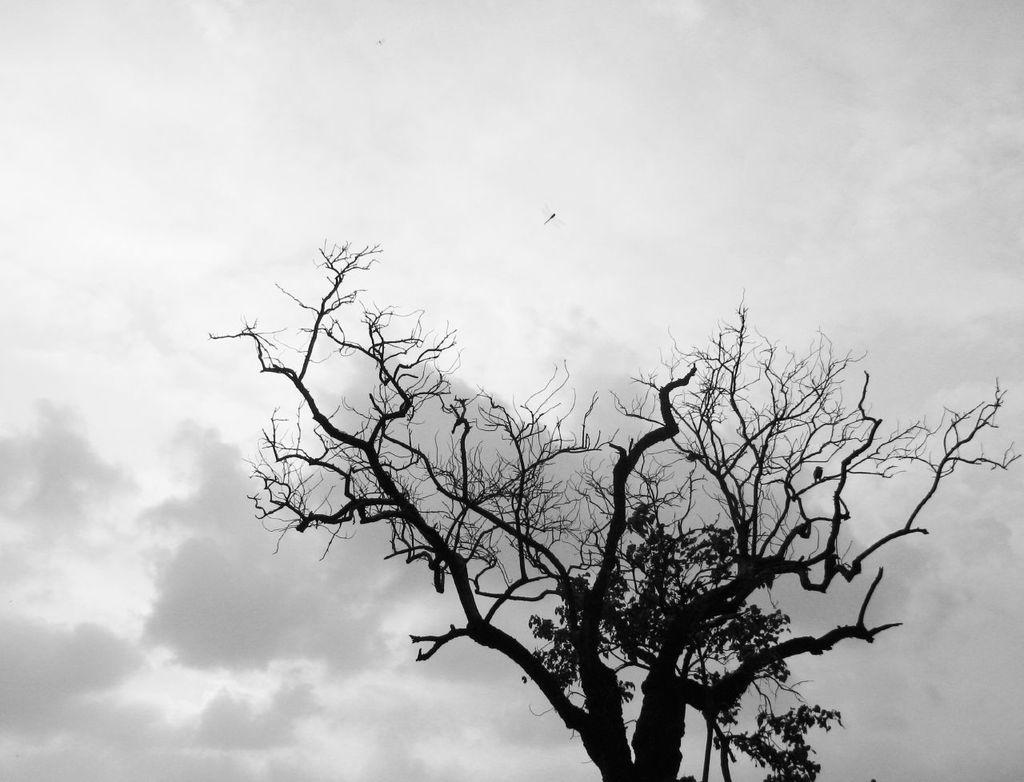What type of living organisms can be seen in the image? Plants and trees are visible in the image. What other creature can be seen in the image? A dragonfly is present in the air. What is visible in the background of the image? The sky is visible in the image. How would you describe the sky in the image? The sky is fully covered with clouds. How many vans can be seen parked near the trees in the image? There are no vans present in the image; it features plants, trees, a dragonfly, and a cloudy sky. 